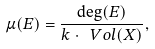Convert formula to latex. <formula><loc_0><loc_0><loc_500><loc_500>\mu ( E ) = \frac { \deg ( E ) } { k \cdot \ V o l ( X ) } ,</formula> 